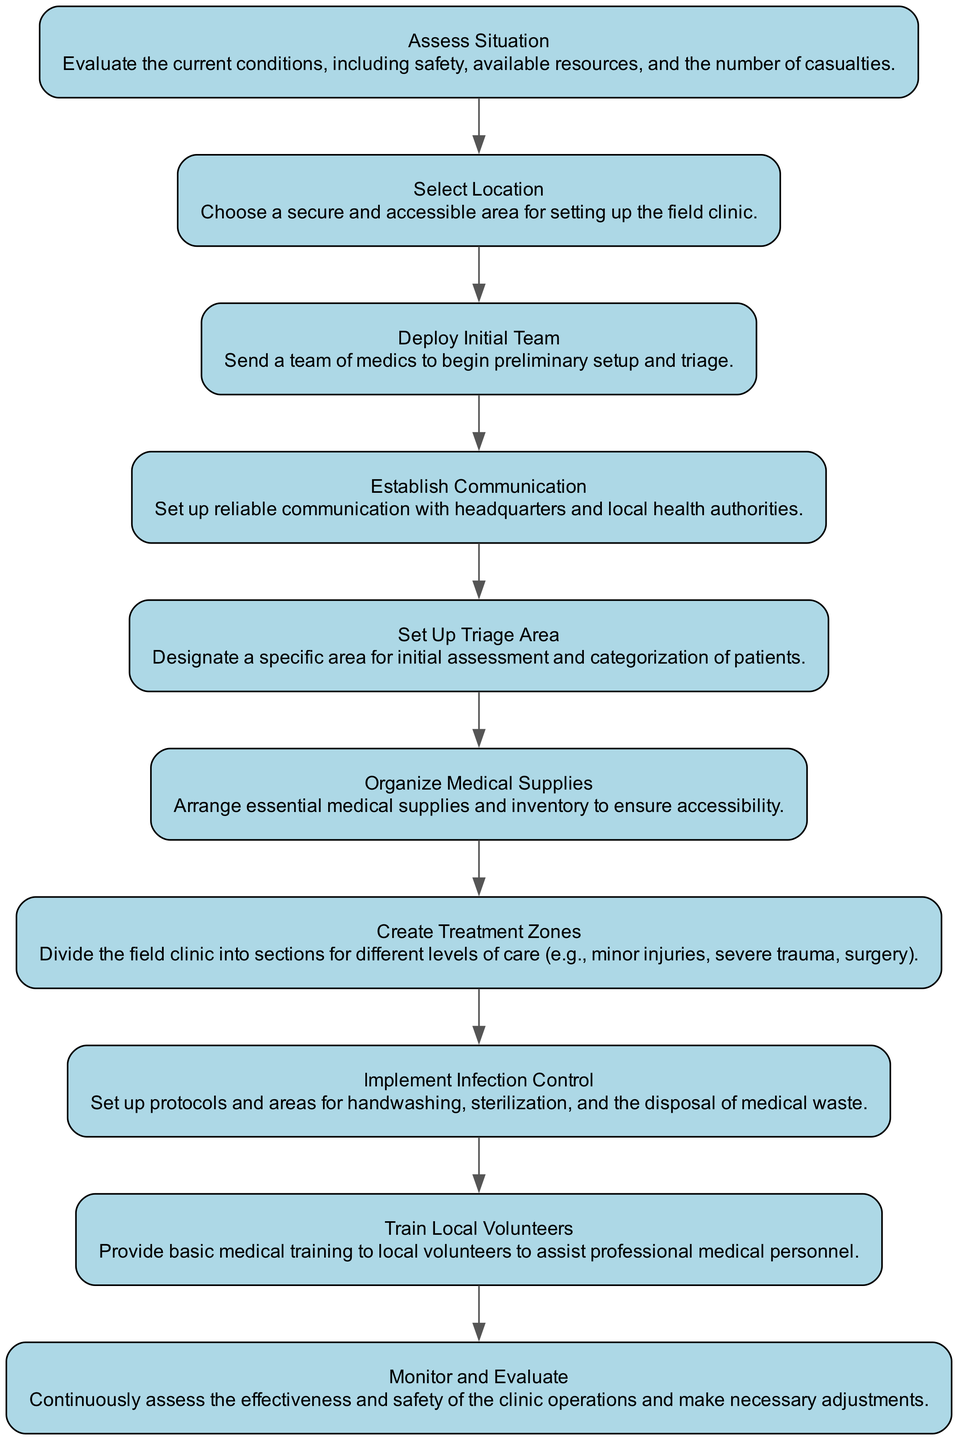What is the first step in the workflow? The workflow begins with the "Assess Situation" node, which is the first element in the flow chart and indicates the initial action to evaluate current conditions.
Answer: Assess Situation How many total nodes are in the diagram? When counting the nodes listed in the diagram from "Assess Situation" to "Monitor and Evaluate", we find there are ten distinct elements representing each step in the workflow.
Answer: Ten Which node comes directly after "Deploy Initial Team"? The "Establish Communication" node follows "Deploy Initial Team" in the sequence, indicating the next action after the team is deployed.
Answer: Establish Communication What is the main purpose of the "Train Local Volunteers" step? The purpose of this step is to provide basic medical training to local volunteers, enhancing their ability to assist medical personnel effectively.
Answer: Provide training Describe the relationship between the "Set Up Triage Area" and "Create Treatment Zones" nodes. "Set Up Triage Area" leads directly into "Create Treatment Zones," indicating a sequence where initial patient assessment transitions into organizing areas for differing levels of medical care.
Answer: Direct sequence How many medical-related tasks are there before "Monitor and Evaluate"? Counting the steps preceding "Monitor and Evaluate," we find there are eight tasks related to setting up and organizing the field clinic before this evaluation step can occur.
Answer: Eight What is the final step in the workflow? The last step is "Monitor and Evaluate," which ensures continuous assessment of the clinic operations for safety and effectiveness after all setups are completed.
Answer: Monitor and Evaluate What does the "Implement Infection Control" node emphasize? This node emphasizes the importance of setting up protocols for hygiene practices like handwashing and sterilization, crucial for preventing infection in a medical setting.
Answer: Infection control protocols In what step are medical supplies organized? The "Organize Medical Supplies" node specifically focuses on the arrangement and inventory of essential supplies necessary for the field clinic's operations.
Answer: Organize Medical Supplies 